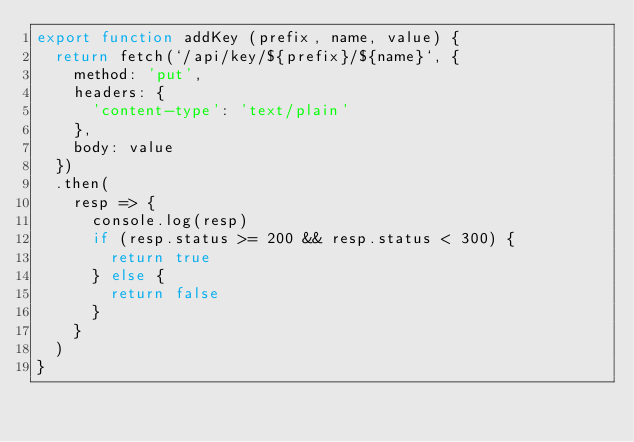Convert code to text. <code><loc_0><loc_0><loc_500><loc_500><_JavaScript_>export function addKey (prefix, name, value) {
  return fetch(`/api/key/${prefix}/${name}`, {
    method: 'put',
    headers: {
      'content-type': 'text/plain'
    },
    body: value
  })
  .then(
    resp => {
      console.log(resp)
      if (resp.status >= 200 && resp.status < 300) {
        return true
      } else {
        return false
      }
    }
  )
}
</code> 